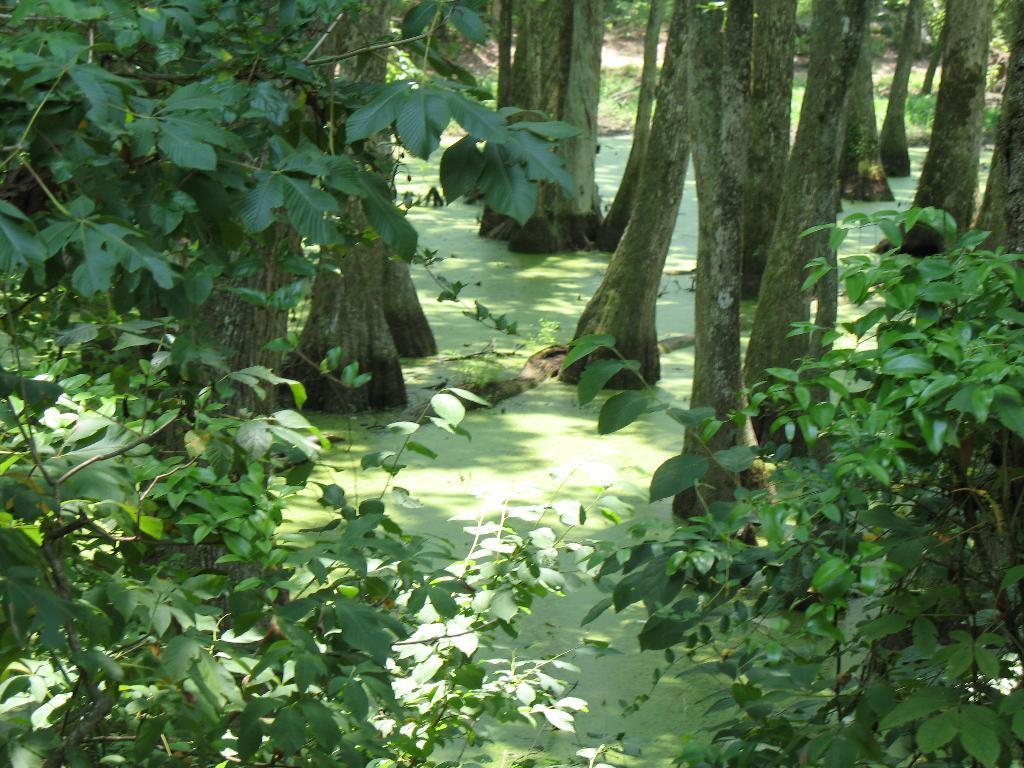How would you summarize this image in a sentence or two? In this picture there are trees. At the bottom it looks like water and there is a tree branch. At the back there is grass 